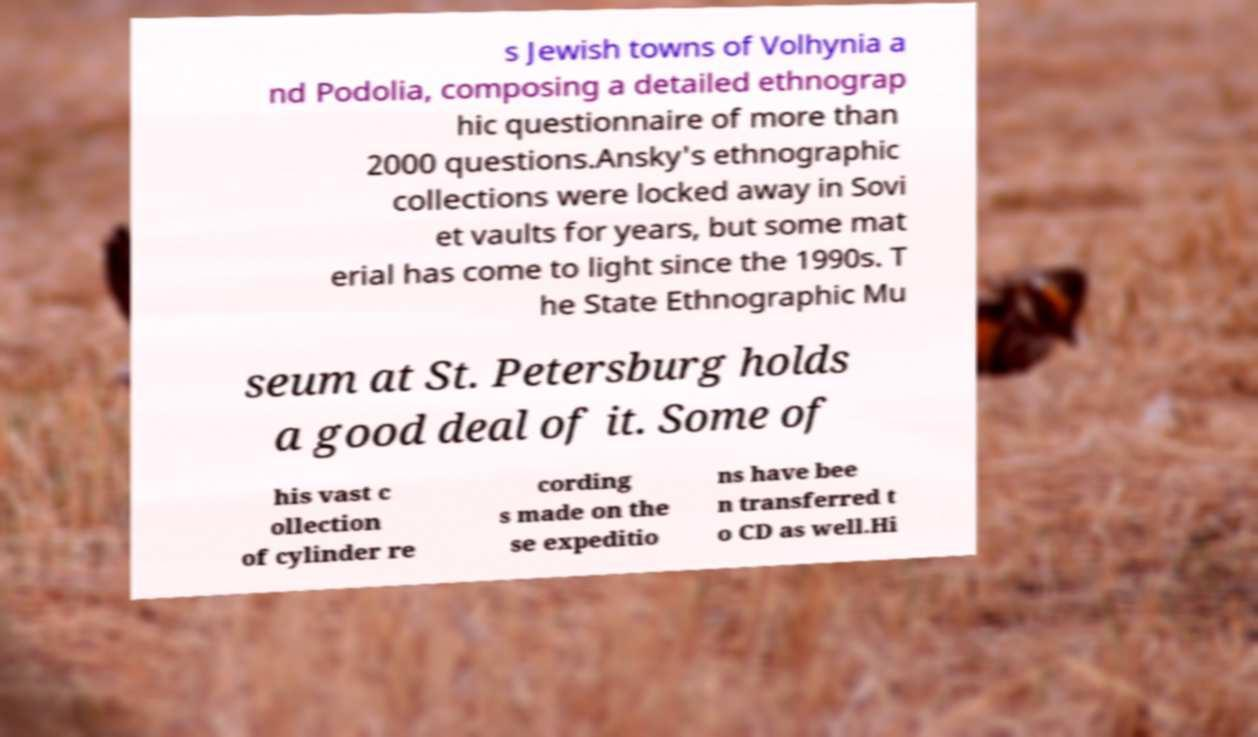Please read and relay the text visible in this image. What does it say? s Jewish towns of Volhynia a nd Podolia, composing a detailed ethnograp hic questionnaire of more than 2000 questions.Ansky's ethnographic collections were locked away in Sovi et vaults for years, but some mat erial has come to light since the 1990s. T he State Ethnographic Mu seum at St. Petersburg holds a good deal of it. Some of his vast c ollection of cylinder re cording s made on the se expeditio ns have bee n transferred t o CD as well.Hi 